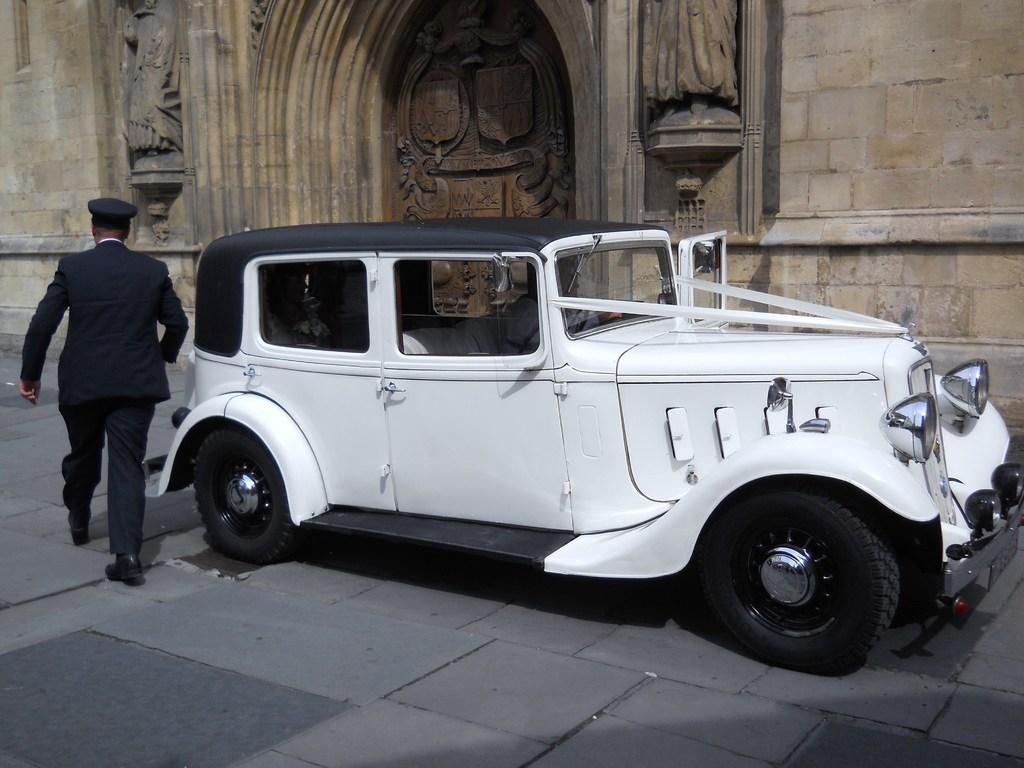What type of vehicle is in the image? There is a white car in the image. Is there anyone inside the car? Yes, a human is sitting inside the white car. What is the person inside the car doing? The person is exhibiting leg movement, suggesting they are walking. What is the medium of the image? The image is a stone carving. What type of plastic material is used to make the chair in the image? There is no chair present in the image; it features a white car with a person inside. 